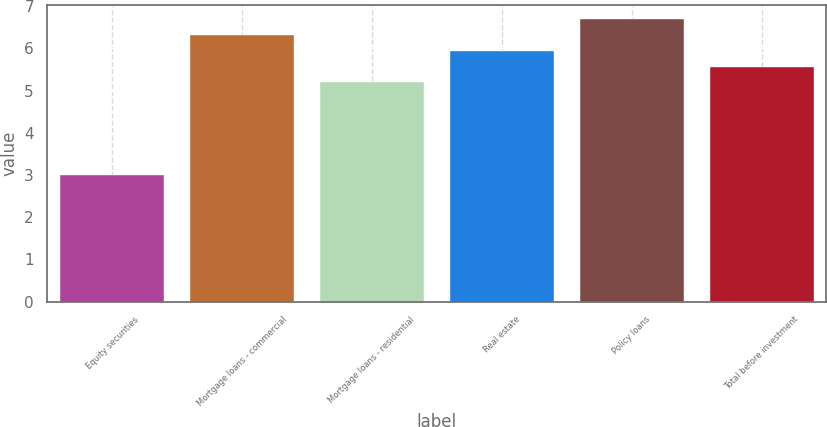<chart> <loc_0><loc_0><loc_500><loc_500><bar_chart><fcel>Equity securities<fcel>Mortgage loans - commercial<fcel>Mortgage loans - residential<fcel>Real estate<fcel>Policy loans<fcel>Total before investment<nl><fcel>3<fcel>6.31<fcel>5.2<fcel>5.94<fcel>6.7<fcel>5.57<nl></chart> 